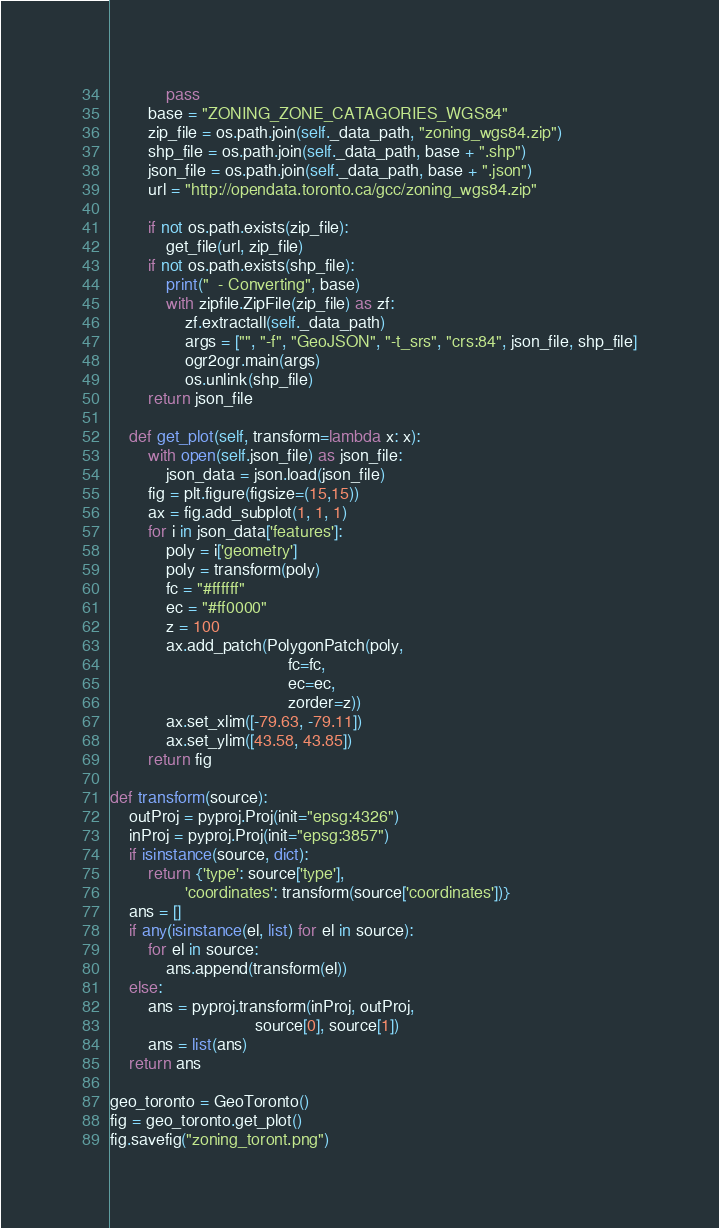<code> <loc_0><loc_0><loc_500><loc_500><_Python_>            pass
        base = "ZONING_ZONE_CATAGORIES_WGS84"
        zip_file = os.path.join(self._data_path, "zoning_wgs84.zip")
        shp_file = os.path.join(self._data_path, base + ".shp")
        json_file = os.path.join(self._data_path, base + ".json")
        url = "http://opendata.toronto.ca/gcc/zoning_wgs84.zip"

        if not os.path.exists(zip_file):
            get_file(url, zip_file)
        if not os.path.exists(shp_file):
            print("  - Converting", base)
            with zipfile.ZipFile(zip_file) as zf:
                zf.extractall(self._data_path)
                args = ["", "-f", "GeoJSON", "-t_srs", "crs:84", json_file, shp_file]
                ogr2ogr.main(args)
                os.unlink(shp_file)
        return json_file

    def get_plot(self, transform=lambda x: x):
        with open(self.json_file) as json_file:
            json_data = json.load(json_file)
        fig = plt.figure(figsize=(15,15))
        ax = fig.add_subplot(1, 1, 1)
        for i in json_data['features']:
            poly = i['geometry']
            poly = transform(poly)
            fc = "#ffffff"
            ec = "#ff0000"
            z = 100
            ax.add_patch(PolygonPatch(poly,
                                      fc=fc,
                                      ec=ec,
                                      zorder=z))
            ax.set_xlim([-79.63, -79.11])
            ax.set_ylim([43.58, 43.85])
        return fig

def transform(source):
    outProj = pyproj.Proj(init="epsg:4326")
    inProj = pyproj.Proj(init="epsg:3857")
    if isinstance(source, dict):
        return {'type': source['type'],
                'coordinates': transform(source['coordinates'])}
    ans = []
    if any(isinstance(el, list) for el in source):
        for el in source:
            ans.append(transform(el))
    else:
        ans = pyproj.transform(inProj, outProj,
                               source[0], source[1])
        ans = list(ans)
    return ans

geo_toronto = GeoToronto()
fig = geo_toronto.get_plot()
fig.savefig("zoning_toront.png")
</code> 